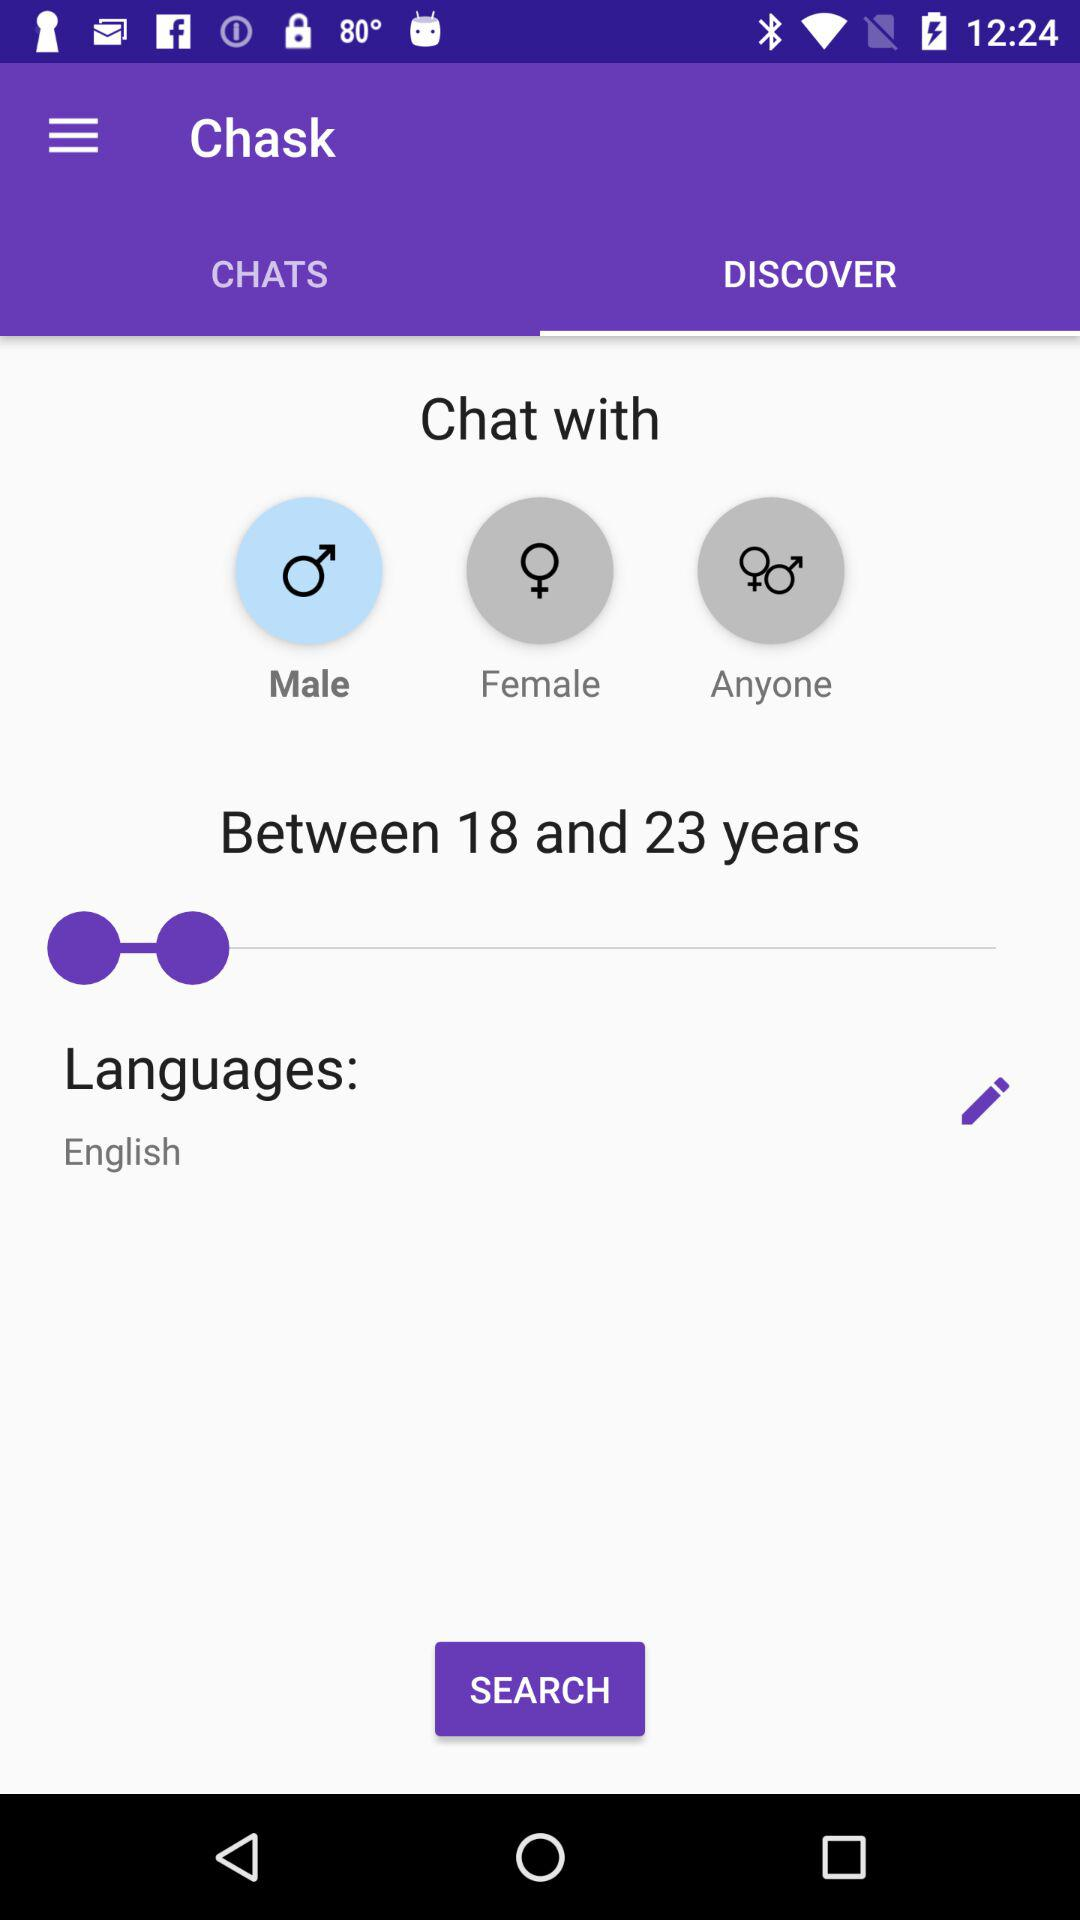What is the selected language? The selected language is English. 